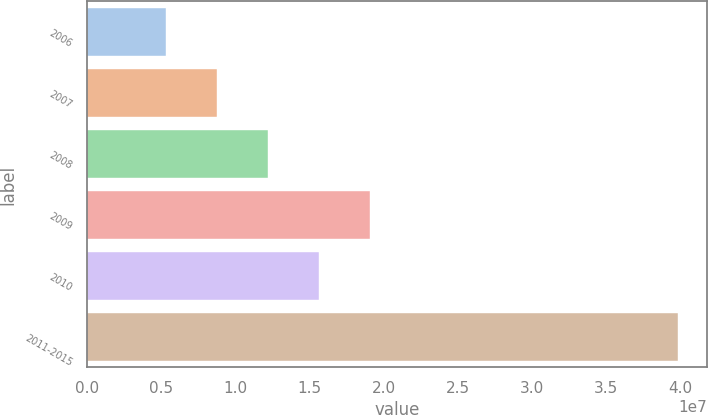Convert chart to OTSL. <chart><loc_0><loc_0><loc_500><loc_500><bar_chart><fcel>2006<fcel>2007<fcel>2008<fcel>2009<fcel>2010<fcel>2011-2015<nl><fcel>5.29e+06<fcel>8.7413e+06<fcel>1.21926e+07<fcel>1.90952e+07<fcel>1.56439e+07<fcel>3.9803e+07<nl></chart> 